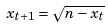<formula> <loc_0><loc_0><loc_500><loc_500>x _ { t + 1 } = \sqrt { n - x _ { t } }</formula> 